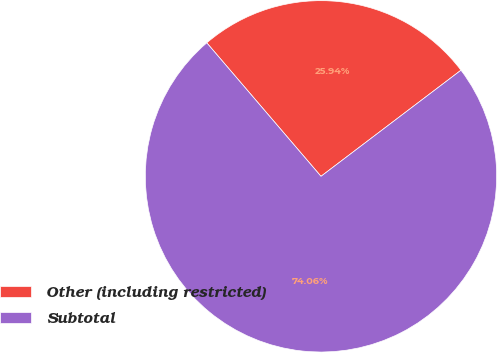Convert chart to OTSL. <chart><loc_0><loc_0><loc_500><loc_500><pie_chart><fcel>Other (including restricted)<fcel>Subtotal<nl><fcel>25.94%<fcel>74.06%<nl></chart> 